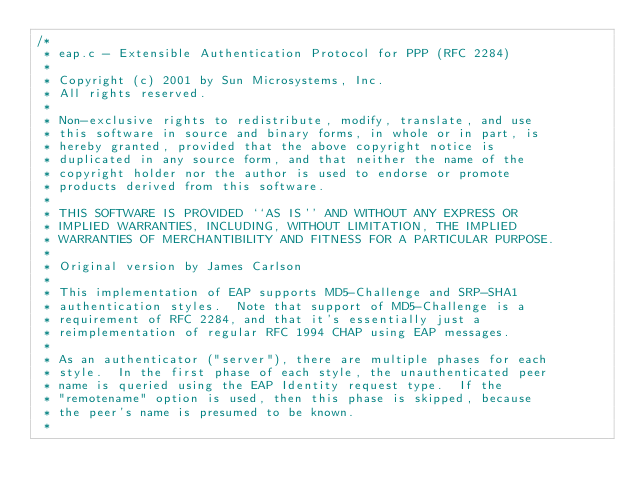<code> <loc_0><loc_0><loc_500><loc_500><_C_>/*
 * eap.c - Extensible Authentication Protocol for PPP (RFC 2284)
 *
 * Copyright (c) 2001 by Sun Microsystems, Inc.
 * All rights reserved.
 *
 * Non-exclusive rights to redistribute, modify, translate, and use
 * this software in source and binary forms, in whole or in part, is
 * hereby granted, provided that the above copyright notice is
 * duplicated in any source form, and that neither the name of the
 * copyright holder nor the author is used to endorse or promote
 * products derived from this software.
 *
 * THIS SOFTWARE IS PROVIDED ``AS IS'' AND WITHOUT ANY EXPRESS OR
 * IMPLIED WARRANTIES, INCLUDING, WITHOUT LIMITATION, THE IMPLIED
 * WARRANTIES OF MERCHANTIBILITY AND FITNESS FOR A PARTICULAR PURPOSE.
 *
 * Original version by James Carlson
 *
 * This implementation of EAP supports MD5-Challenge and SRP-SHA1
 * authentication styles.  Note that support of MD5-Challenge is a
 * requirement of RFC 2284, and that it's essentially just a
 * reimplementation of regular RFC 1994 CHAP using EAP messages.
 *
 * As an authenticator ("server"), there are multiple phases for each
 * style.  In the first phase of each style, the unauthenticated peer
 * name is queried using the EAP Identity request type.  If the
 * "remotename" option is used, then this phase is skipped, because
 * the peer's name is presumed to be known.
 *</code> 